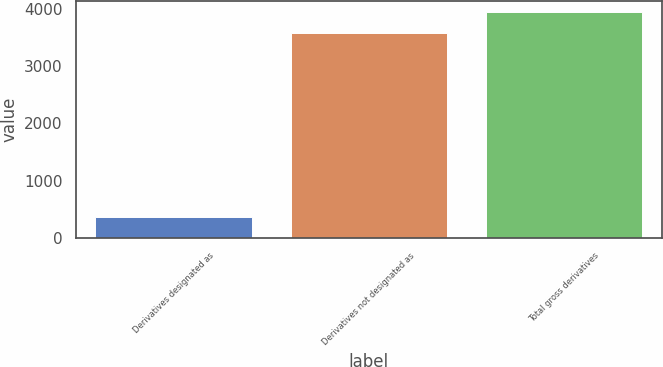Convert chart. <chart><loc_0><loc_0><loc_500><loc_500><bar_chart><fcel>Derivatives designated as<fcel>Derivatives not designated as<fcel>Total gross derivatives<nl><fcel>364<fcel>3570<fcel>3934<nl></chart> 